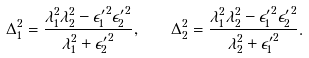<formula> <loc_0><loc_0><loc_500><loc_500>\Delta _ { 1 } ^ { 2 } = \frac { \lambda _ { 1 } ^ { 2 } \lambda _ { 2 } ^ { 2 } - { \epsilon ^ { \prime } _ { 1 } } ^ { 2 } { \epsilon ^ { \prime } _ { 2 } } ^ { 2 } } { \lambda _ { 1 } ^ { 2 } + { \epsilon ^ { \prime } _ { 2 } } ^ { 2 } } , \quad \Delta _ { 2 } ^ { 2 } = \frac { \lambda _ { 1 } ^ { 2 } \lambda _ { 2 } ^ { 2 } - { \epsilon ^ { \prime } _ { 1 } } ^ { 2 } { \epsilon ^ { \prime } _ { 2 } } ^ { 2 } } { \lambda _ { 2 } ^ { 2 } + { \epsilon ^ { \prime } _ { 1 } } ^ { 2 } } .</formula> 